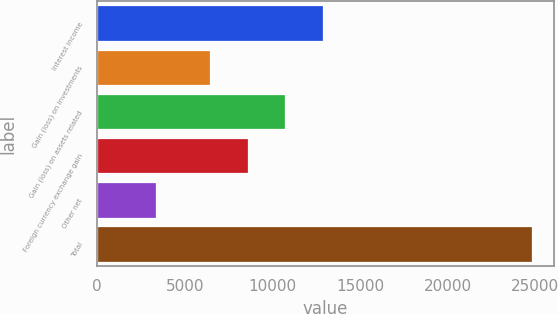Convert chart. <chart><loc_0><loc_0><loc_500><loc_500><bar_chart><fcel>Interest income<fcel>Gain (loss) on investments<fcel>Gain (loss) on assets related<fcel>Foreign currency exchange gain<fcel>Other net<fcel>Total<nl><fcel>12878.5<fcel>6442<fcel>10733<fcel>8587.5<fcel>3364<fcel>24819<nl></chart> 